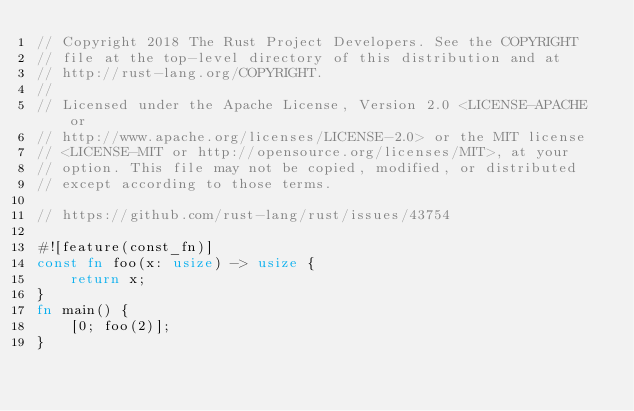Convert code to text. <code><loc_0><loc_0><loc_500><loc_500><_Rust_>// Copyright 2018 The Rust Project Developers. See the COPYRIGHT
// file at the top-level directory of this distribution and at
// http://rust-lang.org/COPYRIGHT.
//
// Licensed under the Apache License, Version 2.0 <LICENSE-APACHE or
// http://www.apache.org/licenses/LICENSE-2.0> or the MIT license
// <LICENSE-MIT or http://opensource.org/licenses/MIT>, at your
// option. This file may not be copied, modified, or distributed
// except according to those terms.

// https://github.com/rust-lang/rust/issues/43754

#![feature(const_fn)]
const fn foo(x: usize) -> usize {
    return x;
}
fn main() {
    [0; foo(2)];
}
</code> 